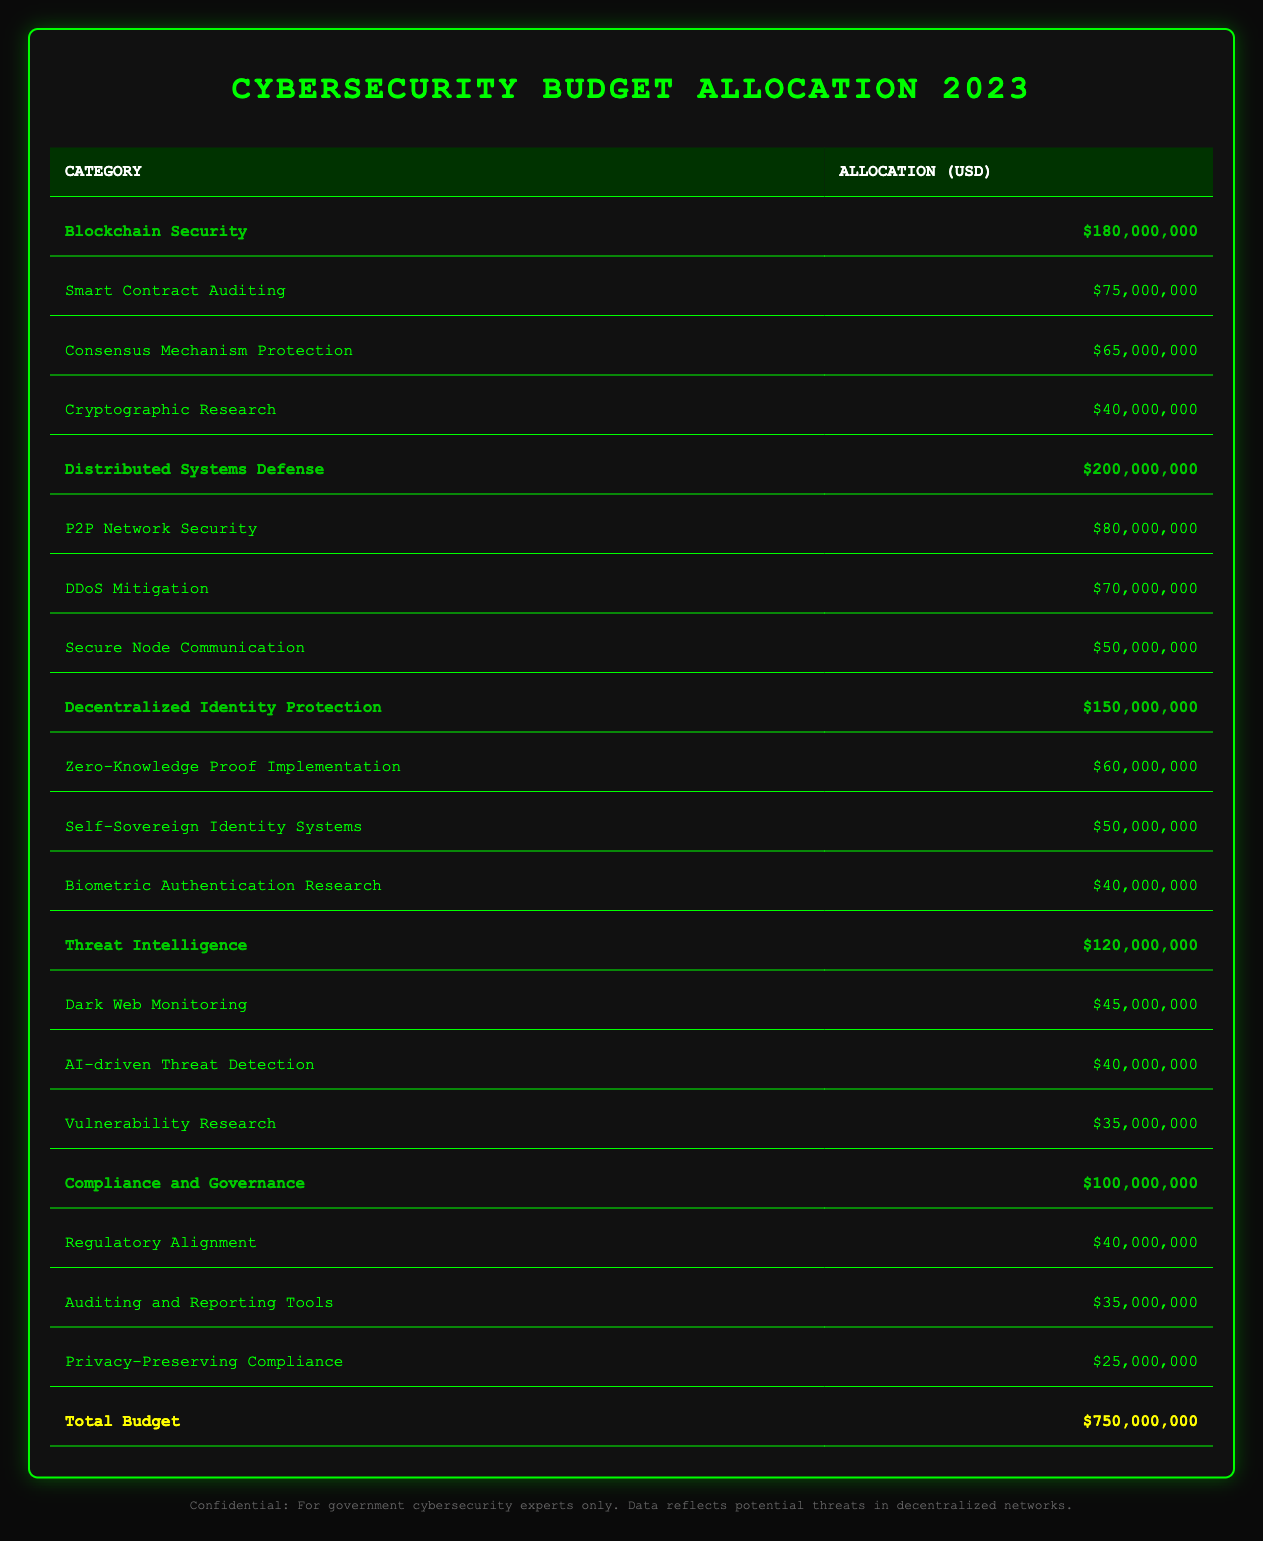What is the total budget allocated for cybersecurity initiatives in 2023? The total budget for cybersecurity initiatives in 2023 is explicitly stated in the table. It shows "Total Budget" with the amount of "750,000,000".
Answer: 750,000,000 How much is allocated to Blockchain Security? The table indicates the category "Blockchain Security" with an allocation amount of "180,000,000".
Answer: 180,000,000 What is the sum of the allocations for Threat Intelligence and Compliance and Governance? First, locate the allocations for each category. Threat Intelligence has an allocation of "120,000,000" and Compliance and Governance has "100,000,000". Adding these together gives "120,000,000 + 100,000,000 = 220,000,000".
Answer: 220,000,000 Is the allocation for DDoS Mitigation greater than the allocation for Secure Node Communication? The allocation for DDoS Mitigation is "70,000,000" and for Secure Node Communication is "50,000,000". Since "70,000,000" is greater than "50,000,000", the statement is true.
Answer: Yes What is the average allocation amount for the subcategories of Distributed Systems Defense? The subcategories under Distributed Systems Defense are P2P Network Security ("80,000,000"), DDoS Mitigation ("70,000,000"), and Secure Node Communication ("50,000,000"). First, sum these amounts: "80,000,000 + 70,000,000 + 50,000,000 = 200,000,000". Then, divide by the number of subcategories (3): "200,000,000 / 3 ≈ 66,666,667".
Answer: 66,666,667 How much more funding is allocated to Decentralized Identity Protection compared to Blockchain Security? The allocation for Decentralized Identity Protection is "150,000,000" and for Blockchain Security is "180,000,000". The difference is calculated by subtracting: "150,000,000 - 180,000,000 = -30,000,000", indicating that Blockchain Security receives more funding.
Answer: 30,000,000 less Which subcategory under Threat Intelligence has the lowest allocation? Looking at the subcategories under Threat Intelligence, the amounts are Dark Web Monitoring ("45,000,000"), AI-driven Threat Detection ("40,000,000"), and Vulnerability Research ("35,000,000"). The lowest amount is "35,000,000" for Vulnerability Research.
Answer: Vulnerability Research Does the total allocation for Decentralized Identity Protection exceed the combined allocations of its subcategories? The total allocation for Decentralized Identity Protection is "150,000,000". The sum of its subcategories is Zero-Knowledge Proof Implementation ("60,000,000") + Self-Sovereign Identity Systems ("50,000,000") + Biometric Authentication Research ("40,000,000") = "150,000,000". Therefore, it does not exceed; they are equal.
Answer: No What percentage of the total budget is allocated to Compliance and Governance? The allocation for Compliance and Governance is "100,000,000". To find the percentage of the total budget, use the formula (Allocation / Total Budget) * 100. Thus, (100,000,000 / 750,000,000) * 100 = 13.33%.
Answer: 13.33% 